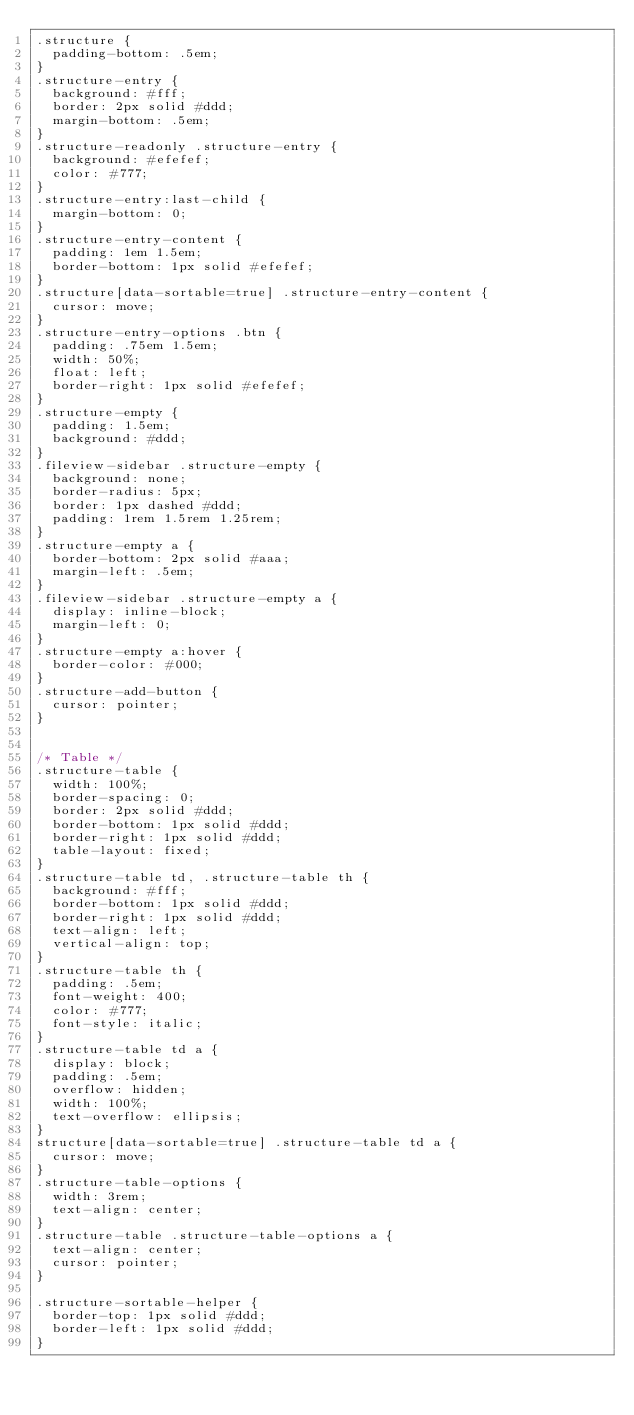<code> <loc_0><loc_0><loc_500><loc_500><_CSS_>.structure {
  padding-bottom: .5em;
}
.structure-entry {
  background: #fff;
  border: 2px solid #ddd;
  margin-bottom: .5em;
}
.structure-readonly .structure-entry {
  background: #efefef;
  color: #777;
}
.structure-entry:last-child {
  margin-bottom: 0;
}
.structure-entry-content {
  padding: 1em 1.5em;
  border-bottom: 1px solid #efefef;
}
.structure[data-sortable=true] .structure-entry-content {
  cursor: move;
}
.structure-entry-options .btn {
  padding: .75em 1.5em;
  width: 50%;
  float: left;
  border-right: 1px solid #efefef;
}
.structure-empty {
  padding: 1.5em;
  background: #ddd;
}
.fileview-sidebar .structure-empty {
  background: none;
  border-radius: 5px;
  border: 1px dashed #ddd;
  padding: 1rem 1.5rem 1.25rem;
}
.structure-empty a {
  border-bottom: 2px solid #aaa;
  margin-left: .5em;
}
.fileview-sidebar .structure-empty a {
  display: inline-block;
  margin-left: 0;
}
.structure-empty a:hover {
  border-color: #000;
}
.structure-add-button {
  cursor: pointer;
}


/* Table */
.structure-table {
  width: 100%;
  border-spacing: 0;
  border: 2px solid #ddd;
  border-bottom: 1px solid #ddd;
  border-right: 1px solid #ddd;
  table-layout: fixed;
}
.structure-table td, .structure-table th {
  background: #fff;
  border-bottom: 1px solid #ddd;
  border-right: 1px solid #ddd;
  text-align: left;
  vertical-align: top;
}
.structure-table th {
  padding: .5em;
  font-weight: 400;
  color: #777;
  font-style: italic;
}
.structure-table td a {
  display: block;
  padding: .5em;
  overflow: hidden;
  width: 100%;
  text-overflow: ellipsis;
}
structure[data-sortable=true] .structure-table td a {
  cursor: move;  
}
.structure-table-options {
  width: 3rem;
  text-align: center;
}
.structure-table .structure-table-options a {
  text-align: center;
  cursor: pointer;
}

.structure-sortable-helper {
  border-top: 1px solid #ddd;
  border-left: 1px solid #ddd;
}
</code> 